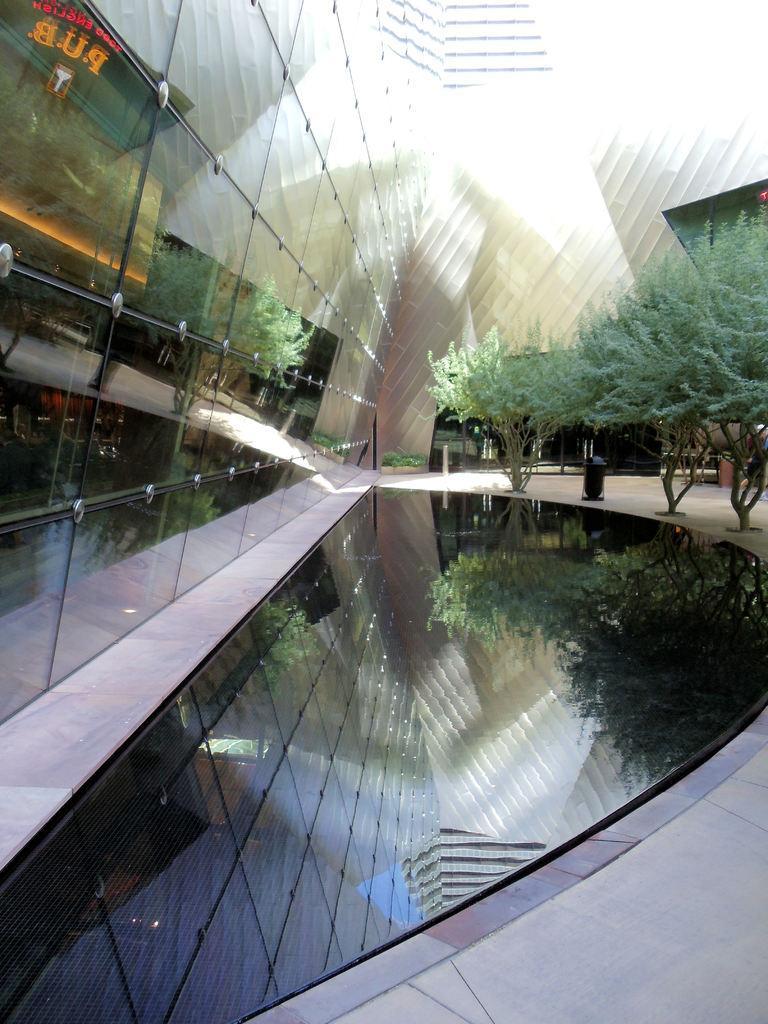Describe this image in one or two sentences. In the given image I can see a glass, building, trees and floor. 